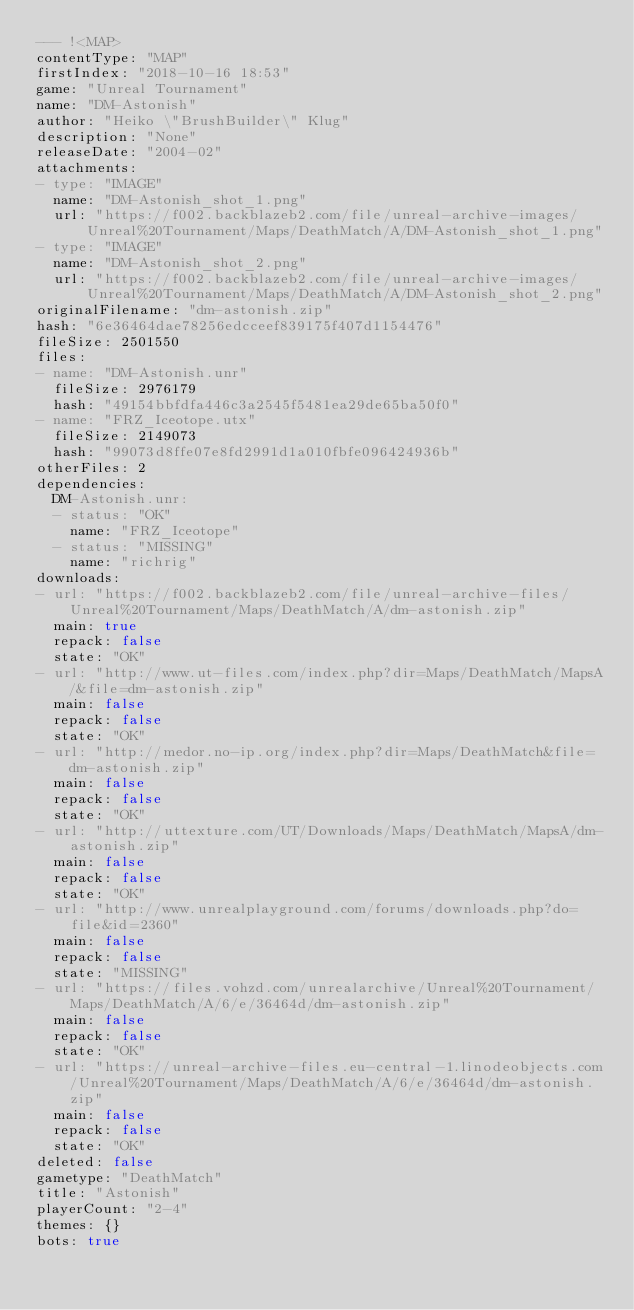Convert code to text. <code><loc_0><loc_0><loc_500><loc_500><_YAML_>--- !<MAP>
contentType: "MAP"
firstIndex: "2018-10-16 18:53"
game: "Unreal Tournament"
name: "DM-Astonish"
author: "Heiko \"BrushBuilder\" Klug"
description: "None"
releaseDate: "2004-02"
attachments:
- type: "IMAGE"
  name: "DM-Astonish_shot_1.png"
  url: "https://f002.backblazeb2.com/file/unreal-archive-images/Unreal%20Tournament/Maps/DeathMatch/A/DM-Astonish_shot_1.png"
- type: "IMAGE"
  name: "DM-Astonish_shot_2.png"
  url: "https://f002.backblazeb2.com/file/unreal-archive-images/Unreal%20Tournament/Maps/DeathMatch/A/DM-Astonish_shot_2.png"
originalFilename: "dm-astonish.zip"
hash: "6e36464dae78256edcceef839175f407d1154476"
fileSize: 2501550
files:
- name: "DM-Astonish.unr"
  fileSize: 2976179
  hash: "49154bbfdfa446c3a2545f5481ea29de65ba50f0"
- name: "FRZ_Iceotope.utx"
  fileSize: 2149073
  hash: "99073d8ffe07e8fd2991d1a010fbfe096424936b"
otherFiles: 2
dependencies:
  DM-Astonish.unr:
  - status: "OK"
    name: "FRZ_Iceotope"
  - status: "MISSING"
    name: "richrig"
downloads:
- url: "https://f002.backblazeb2.com/file/unreal-archive-files/Unreal%20Tournament/Maps/DeathMatch/A/dm-astonish.zip"
  main: true
  repack: false
  state: "OK"
- url: "http://www.ut-files.com/index.php?dir=Maps/DeathMatch/MapsA/&file=dm-astonish.zip"
  main: false
  repack: false
  state: "OK"
- url: "http://medor.no-ip.org/index.php?dir=Maps/DeathMatch&file=dm-astonish.zip"
  main: false
  repack: false
  state: "OK"
- url: "http://uttexture.com/UT/Downloads/Maps/DeathMatch/MapsA/dm-astonish.zip"
  main: false
  repack: false
  state: "OK"
- url: "http://www.unrealplayground.com/forums/downloads.php?do=file&id=2360"
  main: false
  repack: false
  state: "MISSING"
- url: "https://files.vohzd.com/unrealarchive/Unreal%20Tournament/Maps/DeathMatch/A/6/e/36464d/dm-astonish.zip"
  main: false
  repack: false
  state: "OK"
- url: "https://unreal-archive-files.eu-central-1.linodeobjects.com/Unreal%20Tournament/Maps/DeathMatch/A/6/e/36464d/dm-astonish.zip"
  main: false
  repack: false
  state: "OK"
deleted: false
gametype: "DeathMatch"
title: "Astonish"
playerCount: "2-4"
themes: {}
bots: true
</code> 